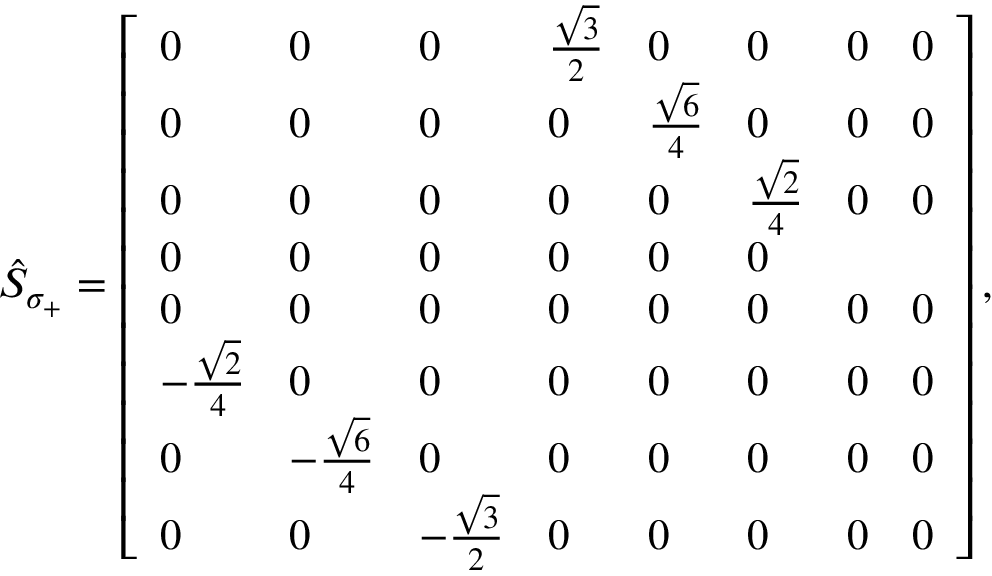<formula> <loc_0><loc_0><loc_500><loc_500>\begin{array} { r } { \hat { S } _ { \sigma _ { + } } = \left [ \begin{array} { l l l l l l l l } { 0 } & { 0 } & { 0 } & { \frac { \sqrt { 3 } } { 2 } } & { 0 } & { 0 } & { 0 } & { 0 } \\ { 0 } & { 0 } & { 0 } & { 0 } & { \frac { \sqrt { 6 } } { 4 } } & { 0 } & { 0 } & { 0 } \\ { 0 } & { 0 } & { 0 } & { 0 } & { 0 } & { \frac { \sqrt { 2 } } { 4 } } & { 0 } & { 0 } \\ { 0 } & { 0 } & { 0 } & { 0 } & { 0 } & { 0 } \\ { 0 } & { 0 } & { 0 } & { 0 } & { 0 } & { 0 } & { 0 } & { 0 } \\ { - \frac { \sqrt { 2 } } { 4 } } & { 0 } & { 0 } & { 0 } & { 0 } & { 0 } & { 0 } & { 0 } \\ { 0 } & { - \frac { \sqrt { 6 } } { 4 } } & { 0 } & { 0 } & { 0 } & { 0 } & { 0 } & { 0 } \\ { 0 } & { 0 } & { - \frac { \sqrt { 3 } } { 2 } } & { 0 } & { 0 } & { 0 } & { 0 } & { 0 } \end{array} \right ] , } \end{array}</formula> 